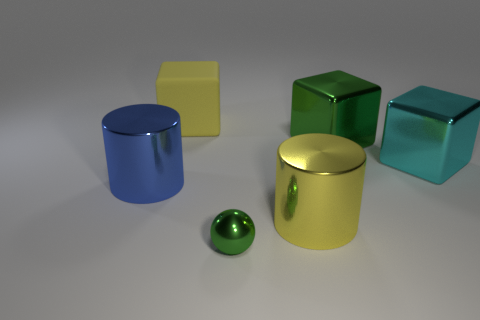Is there any other thing that has the same material as the big yellow cube?
Offer a very short reply. No. There is a yellow object that is behind the yellow metallic object; how many large green blocks are behind it?
Provide a short and direct response. 0. How many red rubber things are there?
Your answer should be compact. 0. Are the large blue object and the large yellow thing that is left of the small sphere made of the same material?
Your response must be concise. No. There is a big cylinder that is right of the large rubber object; does it have the same color as the tiny sphere?
Keep it short and to the point. No. What is the thing that is both in front of the big blue metallic thing and behind the small shiny sphere made of?
Ensure brevity in your answer.  Metal. What size is the blue cylinder?
Provide a short and direct response. Large. There is a big rubber cube; is it the same color as the metallic block in front of the big green shiny object?
Provide a short and direct response. No. How many other things are the same color as the small metal object?
Offer a very short reply. 1. Does the green shiny thing in front of the blue metallic cylinder have the same size as the cube that is on the left side of the big yellow metallic cylinder?
Offer a very short reply. No. 